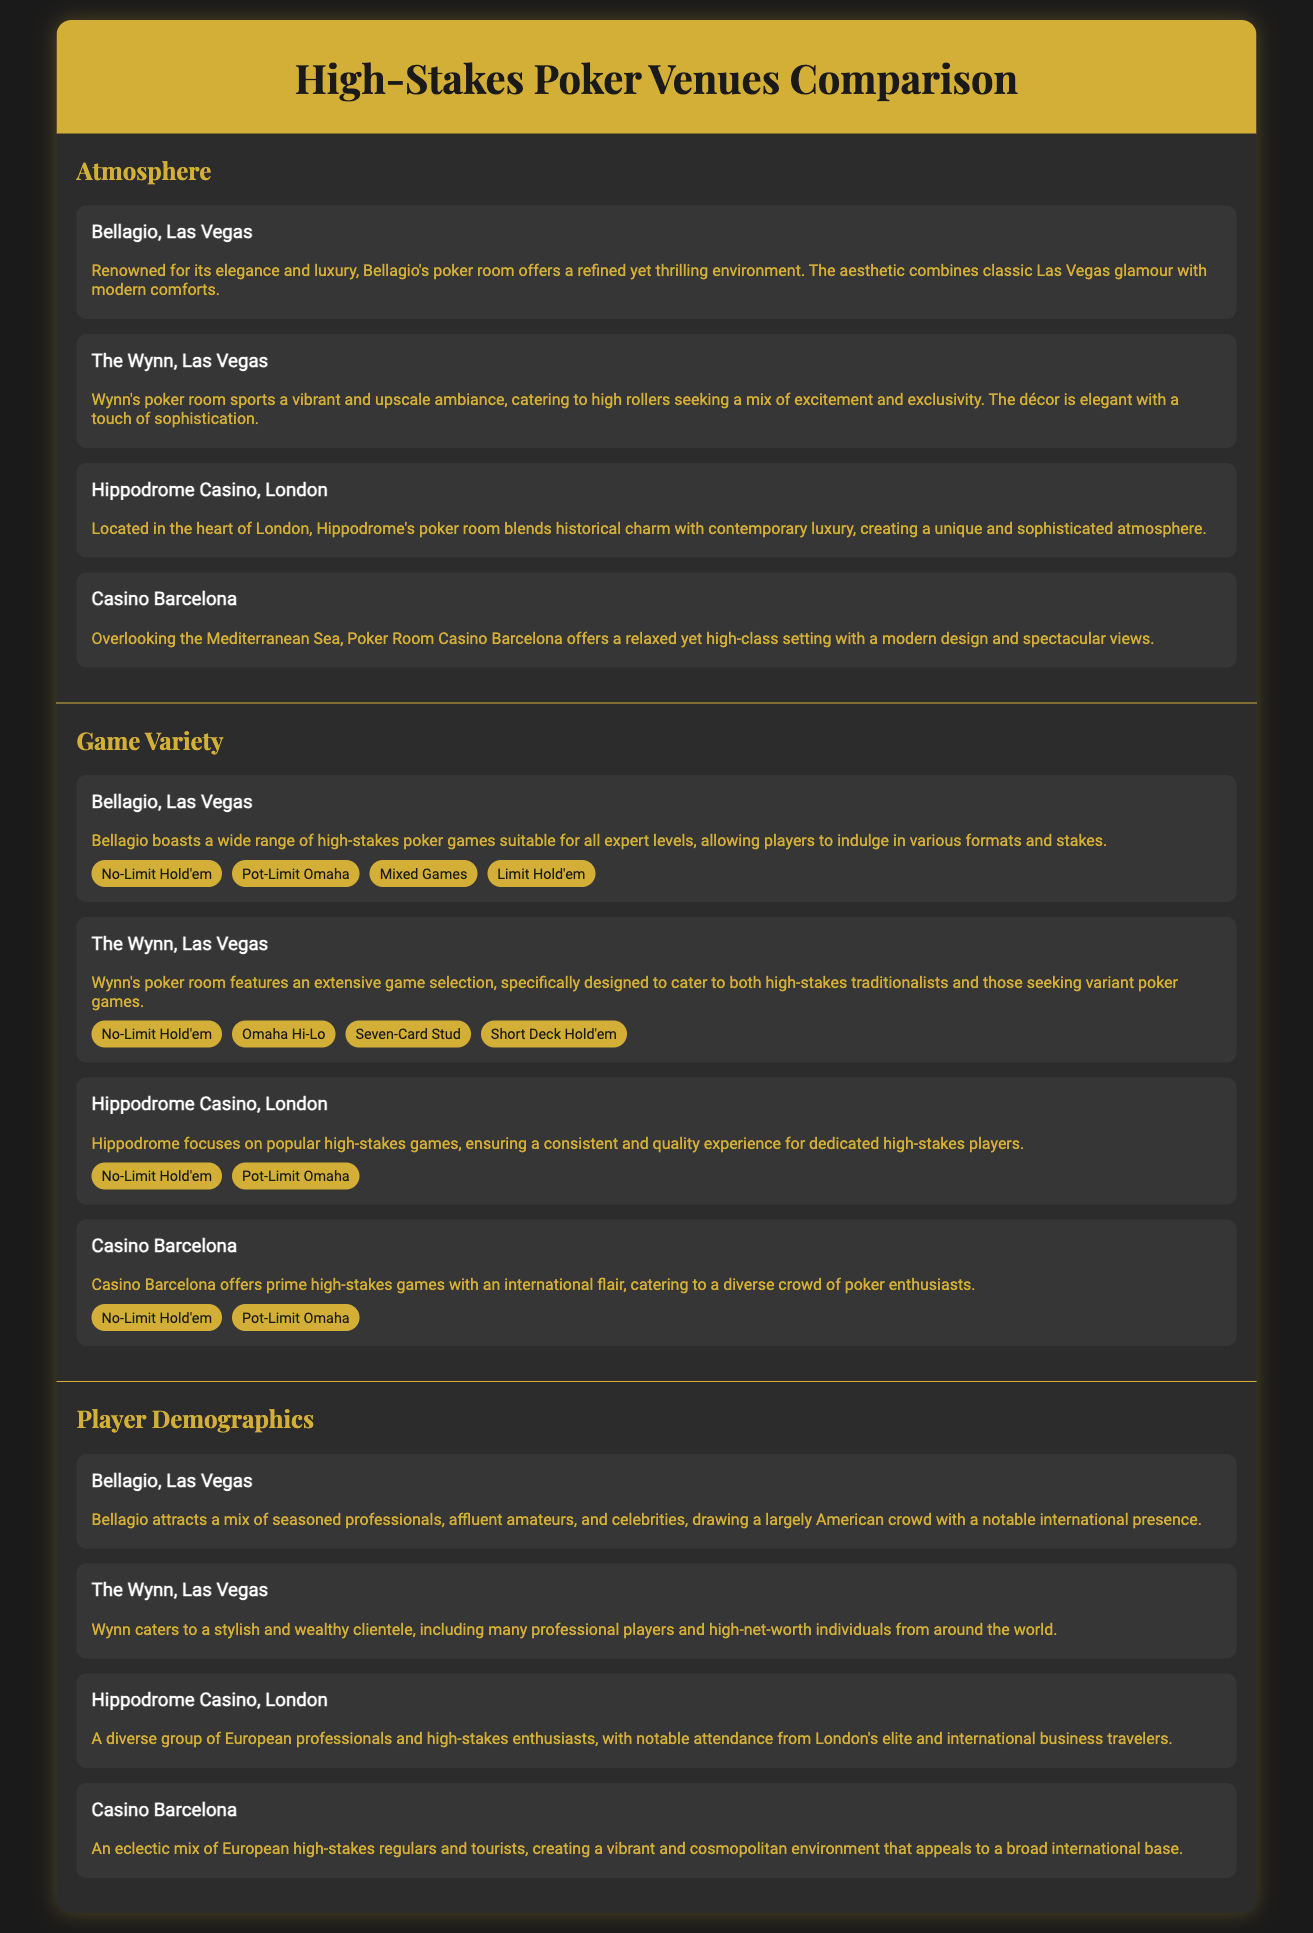What is the atmosphere of Bellagio? The atmosphere of Bellagio is renowned for its elegance and luxury, combining classic Las Vegas glamour with modern comforts.
Answer: Elegant and luxurious Which poker game is featured at Hippodrome Casino? Hippodrome Casino features No-Limit Hold'em and Pot-Limit Omaha as its poker games.
Answer: No-Limit Hold'em What type of clientele does The Wynn cater to? The Wynn caters to a stylish and wealthy clientele, including many professional players and high-net-worth individuals.
Answer: Stylish and wealthy Which venue offers a view of the Mediterranean Sea? Casino Barcelona overlooks the Mediterranean Sea, offering a relaxed yet high-class setting.
Answer: Casino Barcelona How many types of poker games are available at Bellagio? Bellagio boasts four different types of high-stakes poker games, allowing a variety for players.
Answer: Four Which demographic primarily visits Hippodrome Casino? Hippodrome Casino attracts a diverse group of European professionals and high-stakes enthusiasts.
Answer: European professionals What is the main game format at Casino Barcelona? Casino Barcelona focuses on No-Limit Hold'em and Pot-Limit Omaha for its main game formats.
Answer: No-Limit Hold'em What is the unique aspect of game variety at The Wynn? The Wynn features an extensive game selection catering to both high-stakes traditionalists and those seeking variant poker games.
Answer: Extensive game selection What is the primary feature of the atmosphere at Casino Barcelona? Casino Barcelona has a modern design with spectacular views, contributing to its high-class atmosphere.
Answer: Modern design with spectacular views 